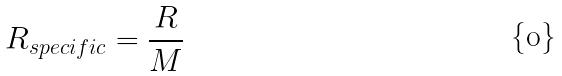<formula> <loc_0><loc_0><loc_500><loc_500>R _ { s p e c i f i c } = \frac { R } { M }</formula> 